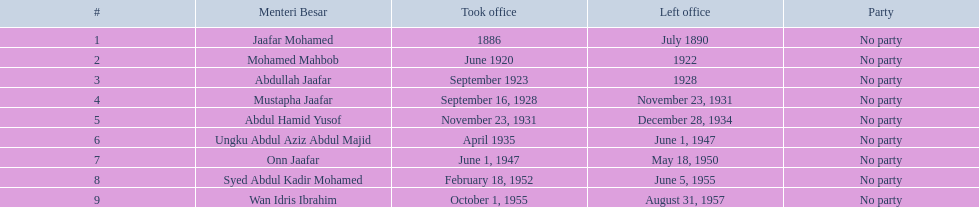Who are all the menteri besars? Jaafar Mohamed, Mohamed Mahbob, Abdullah Jaafar, Mustapha Jaafar, Abdul Hamid Yusof, Ungku Abdul Aziz Abdul Majid, Onn Jaafar, Syed Abdul Kadir Mohamed, Wan Idris Ibrahim. When did each begin their term? 1886, June 1920, September 1923, September 16, 1928, November 23, 1931, April 1935, June 1, 1947, February 18, 1952, October 1, 1955. When did they exit? July 1890, 1922, 1928, November 23, 1931, December 28, 1934, June 1, 1947, May 18, 1950, June 5, 1955, August 31, 1957. And who held the position for the most extended period? Ungku Abdul Aziz Abdul Majid. 